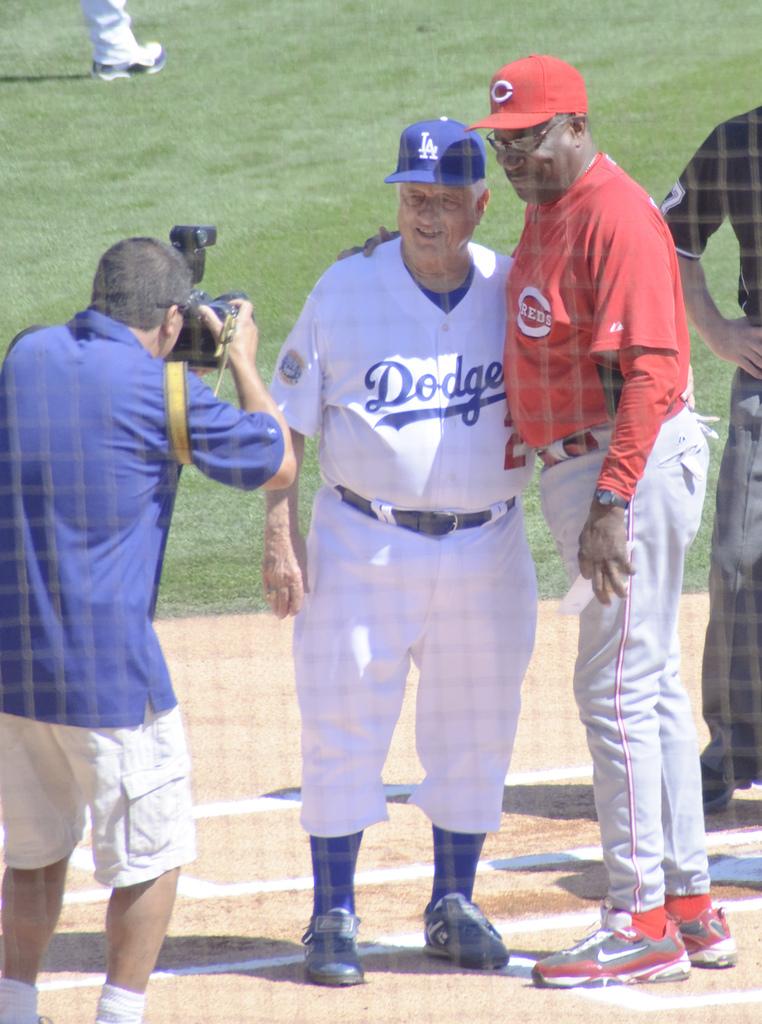What team does the man play for?
Offer a terse response. Dodgers. 